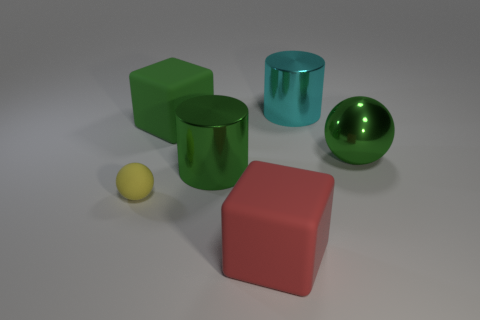Add 2 cyan shiny objects. How many objects exist? 8 Subtract all cubes. How many objects are left? 4 Subtract all large cyan things. Subtract all metal cylinders. How many objects are left? 3 Add 1 large green metal things. How many large green metal things are left? 3 Add 4 big cyan metallic objects. How many big cyan metallic objects exist? 5 Subtract 0 brown balls. How many objects are left? 6 Subtract all cyan cylinders. Subtract all blue cubes. How many cylinders are left? 1 